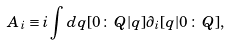Convert formula to latex. <formula><loc_0><loc_0><loc_500><loc_500>A _ { i } \equiv i \int d q [ 0 \, \colon \, Q | q ] \partial _ { i } [ q | 0 \, \colon \, Q ] ,</formula> 